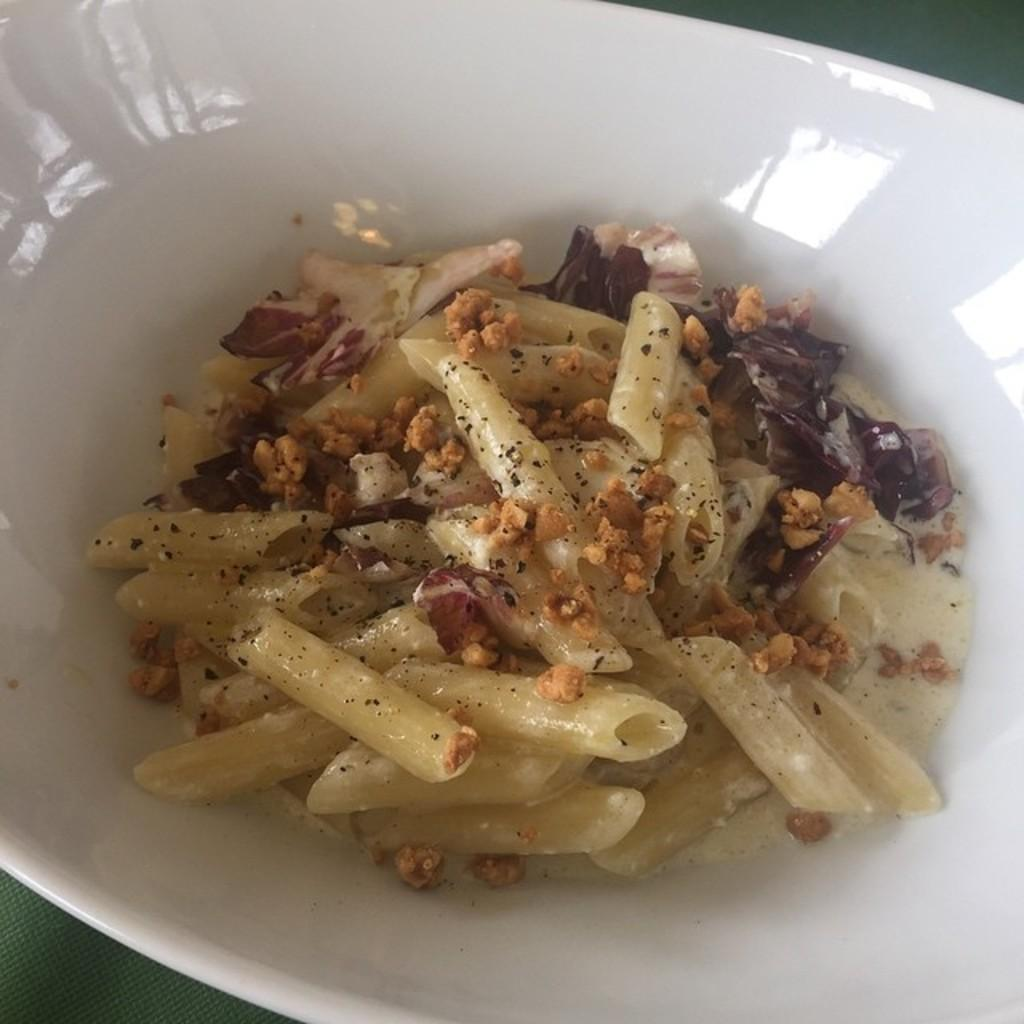What is present in the image that can hold food? There is a bowl in the image. What color is the bowl? The bowl is white in color. What type of food can be seen in the bowl? The bowl contains food made of pasta and other ingredients. What type of celery is used as a spoon in the image? There is no celery or spoon present in the image. The food is made of pasta and other ingredients, but there is no mention of celery or a spoon being used to eat it. 